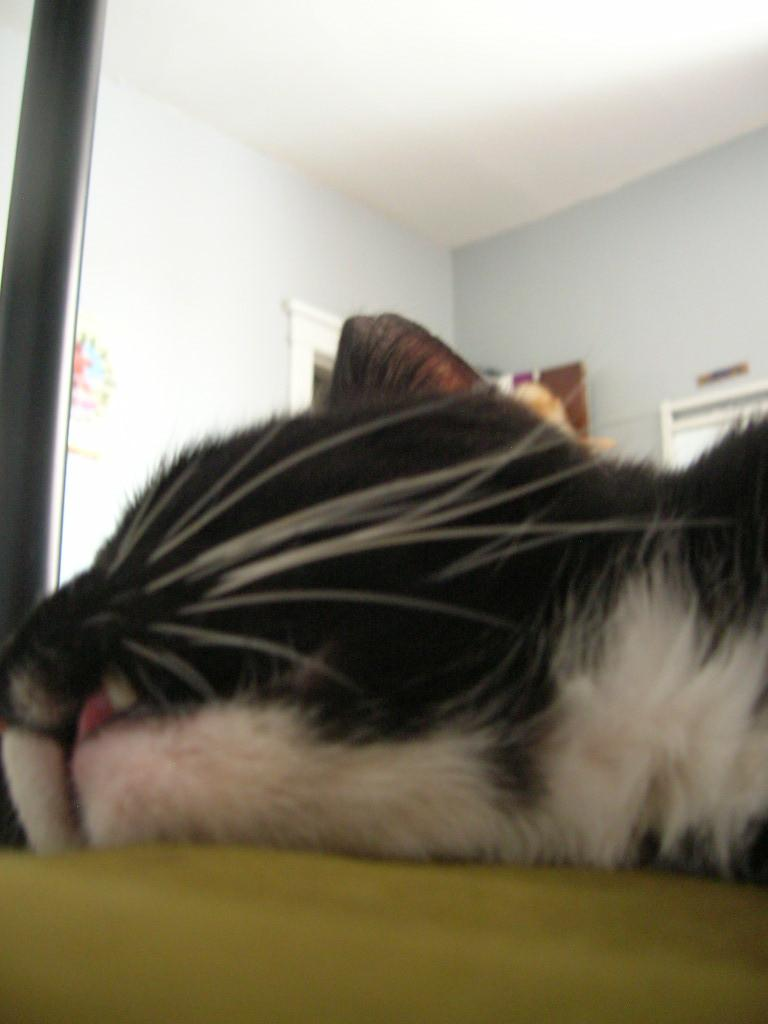What type of animal is in the image? There is a cat in the image. What is the cat doing in the image? The cat is lying on a surface. Where is the surface located in the image? The surface is at the bottom of the image. What can be seen in the background of the image? There is a wall in the background of the image. What is the price of the eye in the image? There is no eye or price present in the image; it features a cat lying on a surface. 